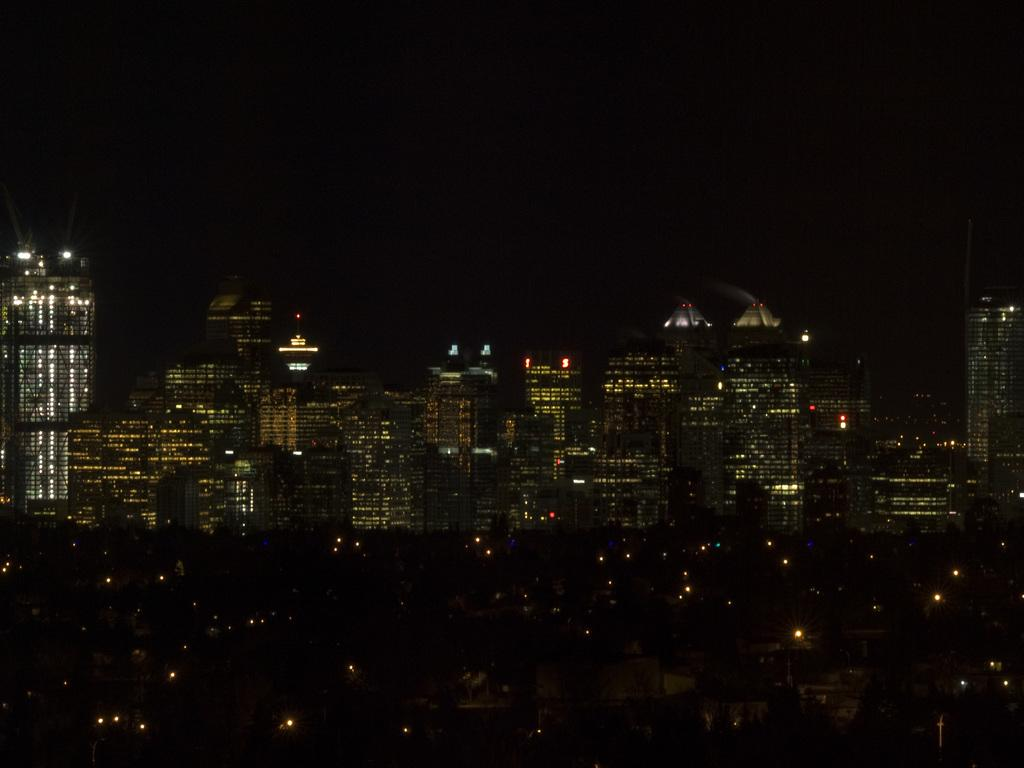What can be seen in the background of the image? There are buildings in the background of the image. What is visible at the top of the image? The sky is visible at the top of the image. When was the image taken? The image was taken during night time. How many plants are visible through the window in the image? There is no window or plant present in the image. What type of shoes is the person wearing in the image? There is no person or shoes visible in the image. 